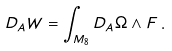Convert formula to latex. <formula><loc_0><loc_0><loc_500><loc_500>D _ { A } W = \int _ { M _ { 8 } } D _ { A } \Omega \wedge F \, .</formula> 